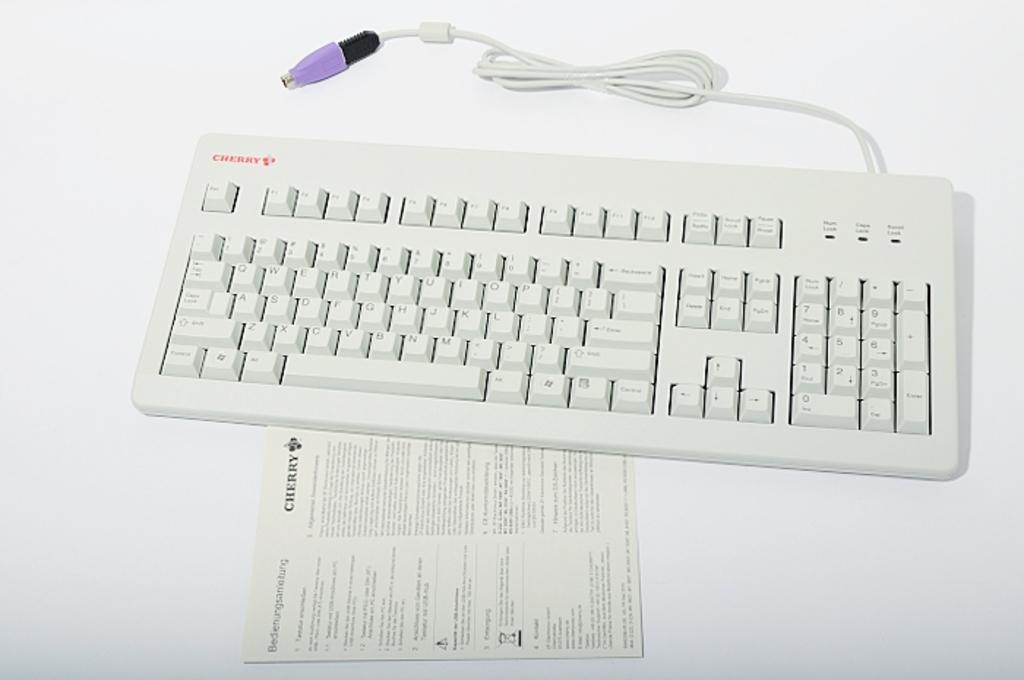What brand of keyboard is this?
Your answer should be very brief. Cherry. What is the brand on the pamphlet?
Offer a very short reply. Cherry. 